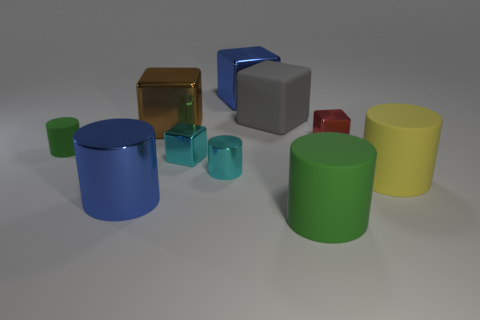Apart from their shapes and sizes, what else can you tell me about these objects? These objects have distinct colors and glossy surfaces that suggest they are likely made of a plastic or metallic material. The way the light is reflecting off their surfaces gives us clues about the texture and material characteristics of each object. Do their colors tell us anything about the objects? Colors can often carry symbolic meanings or be used to categorize items, but in this context, they seem to be chosen more for visual distinction than for any practical or symbolic purpose. The array of colors makes the scene visually interesting and highlights the different shapes present. 